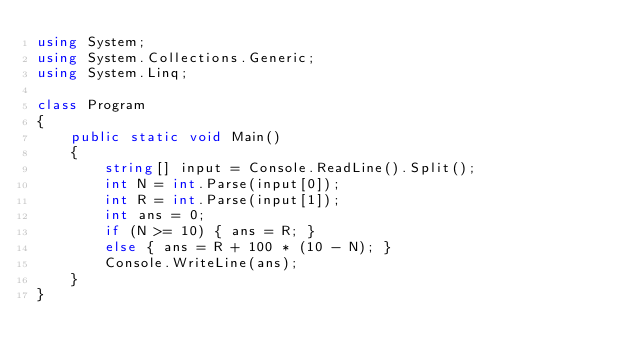Convert code to text. <code><loc_0><loc_0><loc_500><loc_500><_C#_>using System;
using System.Collections.Generic;
using System.Linq;

class Program
{
    public static void Main()
    {
        string[] input = Console.ReadLine().Split();
        int N = int.Parse(input[0]);
        int R = int.Parse(input[1]);
        int ans = 0;
        if (N >= 10) { ans = R; }
        else { ans = R + 100 * (10 - N); }
        Console.WriteLine(ans);
    }
}</code> 